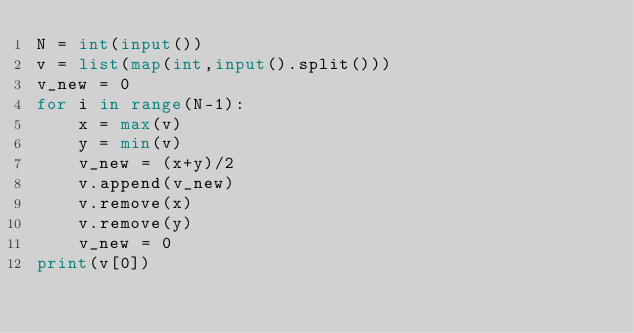Convert code to text. <code><loc_0><loc_0><loc_500><loc_500><_Python_>N = int(input())
v = list(map(int,input().split()))
v_new = 0
for i in range(N-1):
    x = max(v)
    y = min(v)
    v_new = (x+y)/2
    v.append(v_new)
    v.remove(x)
    v.remove(y)
    v_new = 0
print(v[0])</code> 